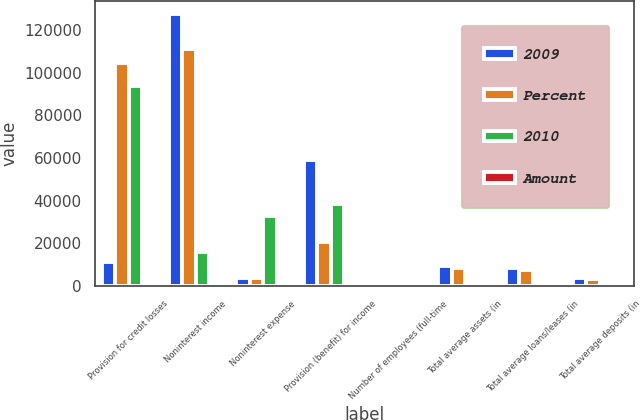<chart> <loc_0><loc_0><loc_500><loc_500><stacked_bar_chart><ecel><fcel>Provision for credit losses<fcel>Noninterest income<fcel>Noninterest expense<fcel>Provision (benefit) for income<fcel>Number of employees (full-time<fcel>Total average assets (in<fcel>Total average loans/leases (in<fcel>Total average deposits (in<nl><fcel>2009<fcel>11013<fcel>127315<fcel>3528<fcel>59147<fcel>623<fcel>9283<fcel>8326<fcel>3882<nl><fcel>Percent<fcel>104705<fcel>111237<fcel>3528<fcel>20710<fcel>538<fcel>8213<fcel>7414<fcel>3174<nl><fcel>2010<fcel>93692<fcel>16078<fcel>32830<fcel>38437<fcel>85<fcel>1070<fcel>912<fcel>708<nl><fcel>Amount<fcel>89<fcel>14<fcel>21<fcel>186<fcel>16<fcel>13<fcel>12<fcel>22<nl></chart> 